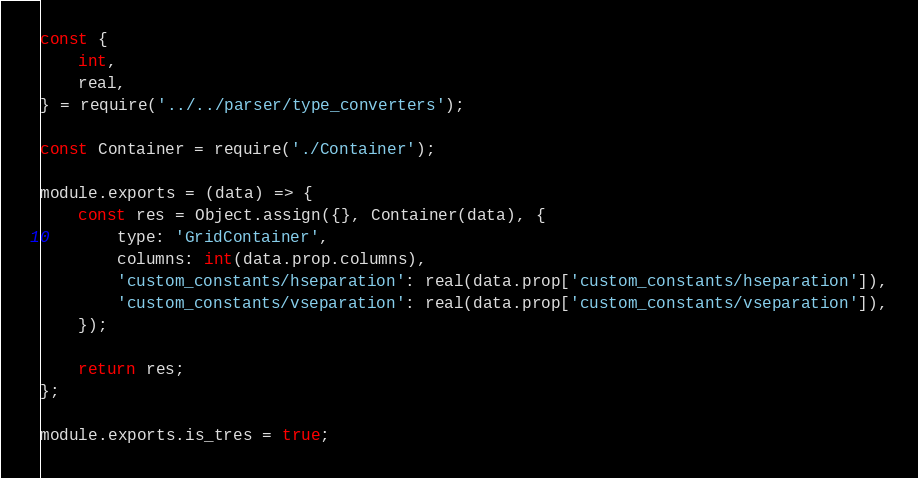Convert code to text. <code><loc_0><loc_0><loc_500><loc_500><_JavaScript_>const {
    int,
    real,
} = require('../../parser/type_converters');

const Container = require('./Container');

module.exports = (data) => {
    const res = Object.assign({}, Container(data), {
        type: 'GridContainer',
        columns: int(data.prop.columns),
        'custom_constants/hseparation': real(data.prop['custom_constants/hseparation']),
        'custom_constants/vseparation': real(data.prop['custom_constants/vseparation']),
    });

    return res;
};

module.exports.is_tres = true;
</code> 